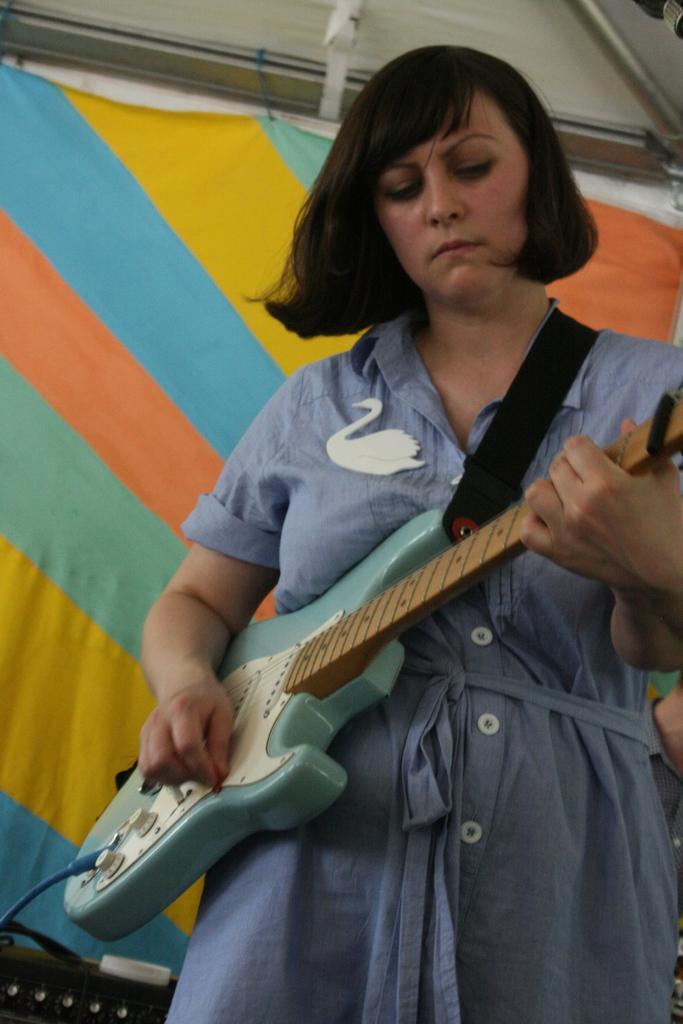How would you summarize this image in a sentence or two? There is a lady who is wearing a blue dress is holding a guitar in her hand. In the background there is a sheet covered. 